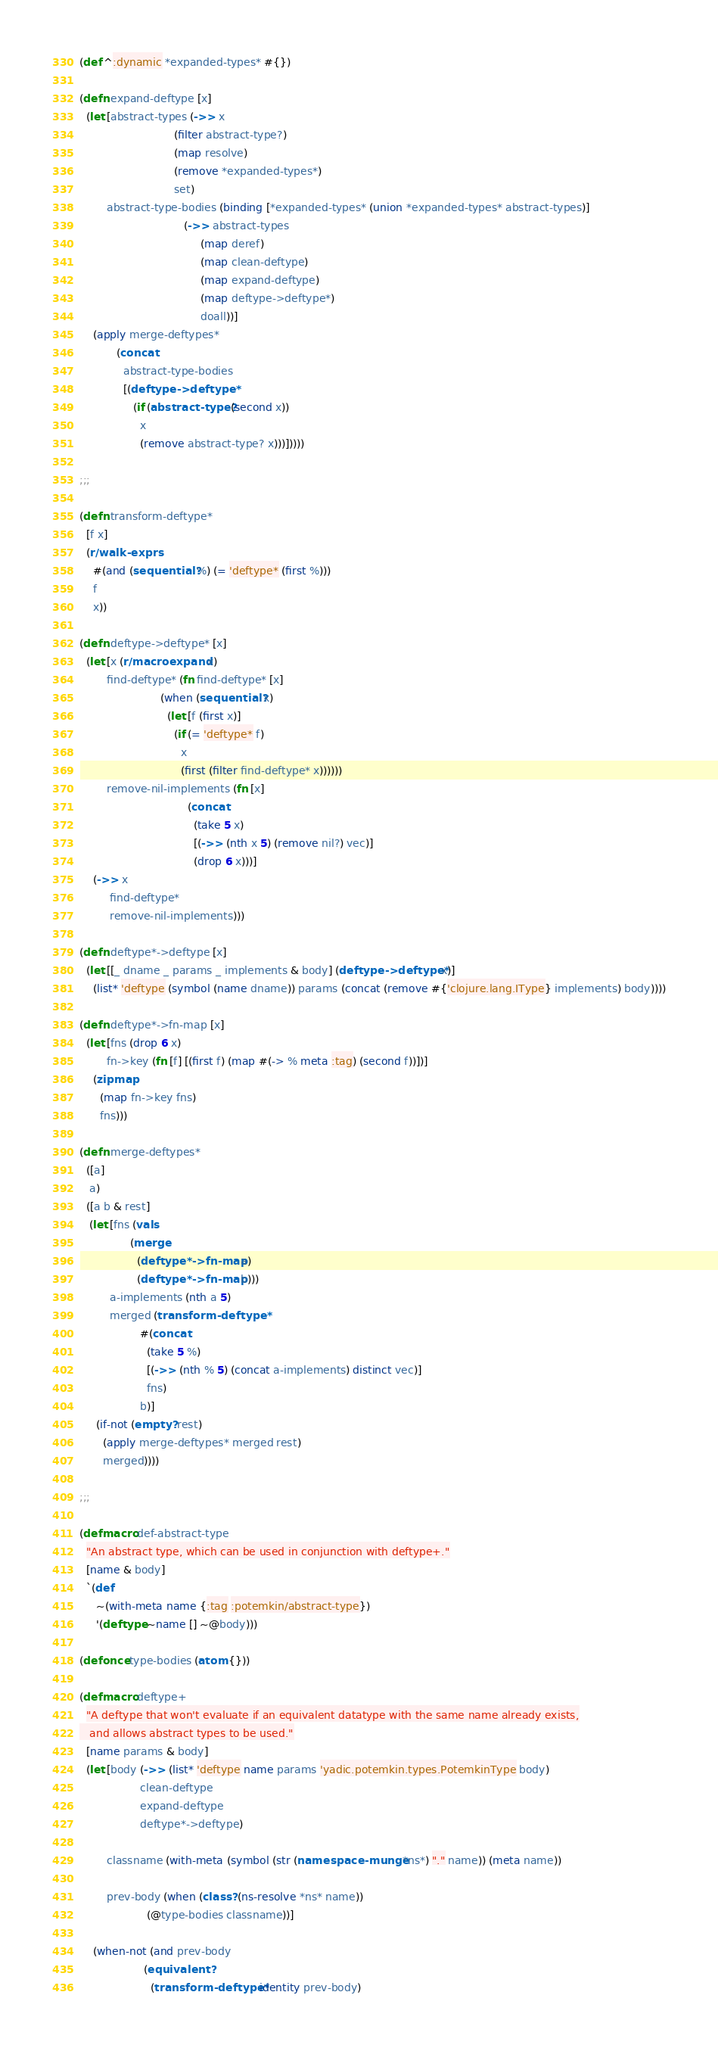<code> <loc_0><loc_0><loc_500><loc_500><_Clojure_>(def ^:dynamic *expanded-types* #{})

(defn expand-deftype [x]
  (let [abstract-types (->> x
                            (filter abstract-type?)
                            (map resolve)
                            (remove *expanded-types*)
                            set)
        abstract-type-bodies (binding [*expanded-types* (union *expanded-types* abstract-types)]
                               (->> abstract-types
                                    (map deref)
                                    (map clean-deftype)
                                    (map expand-deftype)
                                    (map deftype->deftype*)
                                    doall))]
    (apply merge-deftypes*
           (concat
             abstract-type-bodies
             [(deftype->deftype*
                (if (abstract-type? (second x))
                  x
                  (remove abstract-type? x)))]))))

;;;

(defn transform-deftype*
  [f x]
  (r/walk-exprs
    #(and (sequential? %) (= 'deftype* (first %)))
    f
    x))

(defn deftype->deftype* [x]
  (let [x (r/macroexpand x)
        find-deftype* (fn find-deftype* [x]
                        (when (sequential? x)
                          (let [f (first x)]
                            (if (= 'deftype* f)
                              x
                              (first (filter find-deftype* x))))))
        remove-nil-implements (fn [x]
                                (concat
                                  (take 5 x)
                                  [(->> (nth x 5) (remove nil?) vec)]
                                  (drop 6 x)))]
    (->> x
         find-deftype*
         remove-nil-implements)))

(defn deftype*->deftype [x]
  (let [[_ dname _ params _ implements & body] (deftype->deftype* x)]
    (list* 'deftype (symbol (name dname)) params (concat (remove #{'clojure.lang.IType} implements) body))))

(defn deftype*->fn-map [x]
  (let [fns (drop 6 x)
        fn->key (fn [f] [(first f) (map #(-> % meta :tag) (second f))])]
    (zipmap
      (map fn->key fns)
      fns)))

(defn merge-deftypes*
  ([a]
   a)
  ([a b & rest]
   (let [fns (vals
               (merge
                 (deftype*->fn-map a)
                 (deftype*->fn-map b)))
         a-implements (nth a 5)
         merged (transform-deftype*
                  #(concat
                    (take 5 %)
                    [(->> (nth % 5) (concat a-implements) distinct vec)]
                    fns)
                  b)]
     (if-not (empty? rest)
       (apply merge-deftypes* merged rest)
       merged))))

;;;

(defmacro def-abstract-type
  "An abstract type, which can be used in conjunction with deftype+."
  [name & body]
  `(def
     ~(with-meta name {:tag :potemkin/abstract-type})
     '(deftype ~name [] ~@body)))

(defonce type-bodies (atom {}))

(defmacro deftype+
  "A deftype that won't evaluate if an equivalent datatype with the same name already exists,
   and allows abstract types to be used."
  [name params & body]
  (let [body (->> (list* 'deftype name params 'yadic.potemkin.types.PotemkinType body)
                  clean-deftype
                  expand-deftype
                  deftype*->deftype)

        classname (with-meta (symbol (str (namespace-munge *ns*) "." name)) (meta name))

        prev-body (when (class? (ns-resolve *ns* name))
                    (@type-bodies classname))]

    (when-not (and prev-body
                   (equivalent?
                     (transform-deftype* identity prev-body)</code> 